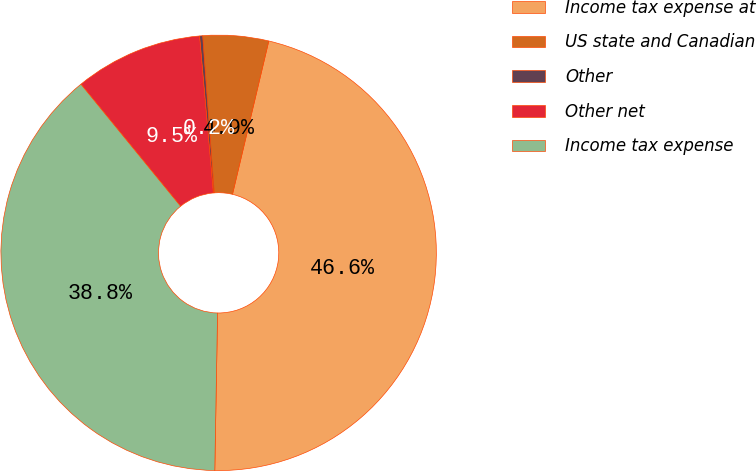Convert chart. <chart><loc_0><loc_0><loc_500><loc_500><pie_chart><fcel>Income tax expense at<fcel>US state and Canadian<fcel>Other<fcel>Other net<fcel>Income tax expense<nl><fcel>46.58%<fcel>4.87%<fcel>0.23%<fcel>9.5%<fcel>38.82%<nl></chart> 